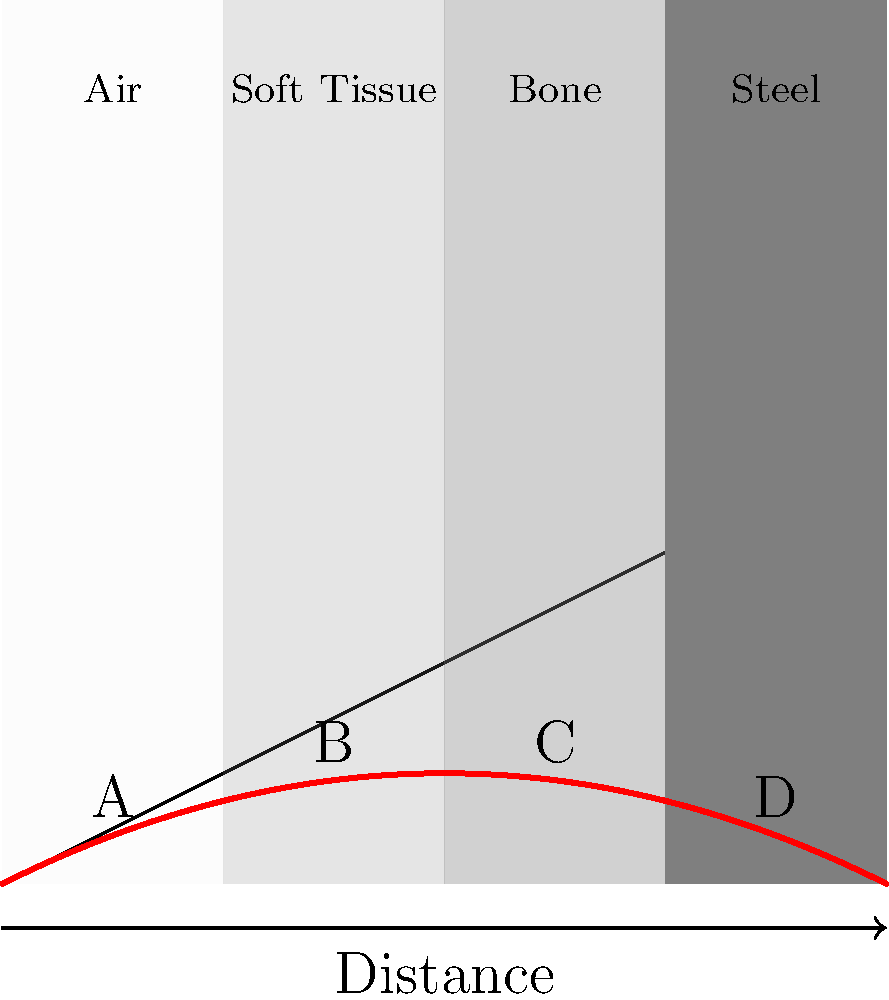Based on the cross-sectional diagram showing a bullet's trajectory through different materials, which point (A, B, C, or D) represents the most significant change in the bullet's path, and what factor is primarily responsible for this change? To answer this question, let's analyze the bullet's trajectory through each material:

1. Air (first section):
   - The bullet's path is relatively straight due to low air resistance.
   - Point A shows minimal deviation.

2. Soft Tissue (second section):
   - The bullet experiences more resistance, causing a slight downward curve.
   - Point B shows a noticeable but not dramatic change.

3. Bone (third section):
   - The density increases significantly compared to soft tissue.
   - Point C shows a more pronounced change in trajectory.

4. Steel (fourth section):
   - This is the densest material in the diagram.
   - Point D shows the most significant change in the bullet's path.

The primary factor responsible for the changes in the bullet's trajectory is the density of the materials it passes through. As the density increases, the bullet experiences more resistance, which causes it to slow down and deviate from its original path.

The equation for the force of resistance can be expressed as:

$$ F_r = \frac{1}{2} \rho v^2 C_d A $$

Where:
$\rho$ = density of the medium
$v$ = velocity of the bullet
$C_d$ = drag coefficient
$A$ = cross-sectional area of the bullet

As the density ($\rho$) increases, the resistance force increases, causing more significant changes in the bullet's trajectory.

Comparing the densities:
Air < Soft Tissue < Bone < Steel

Steel has the highest density, causing the most significant change at point D.
Answer: Point D; material density 